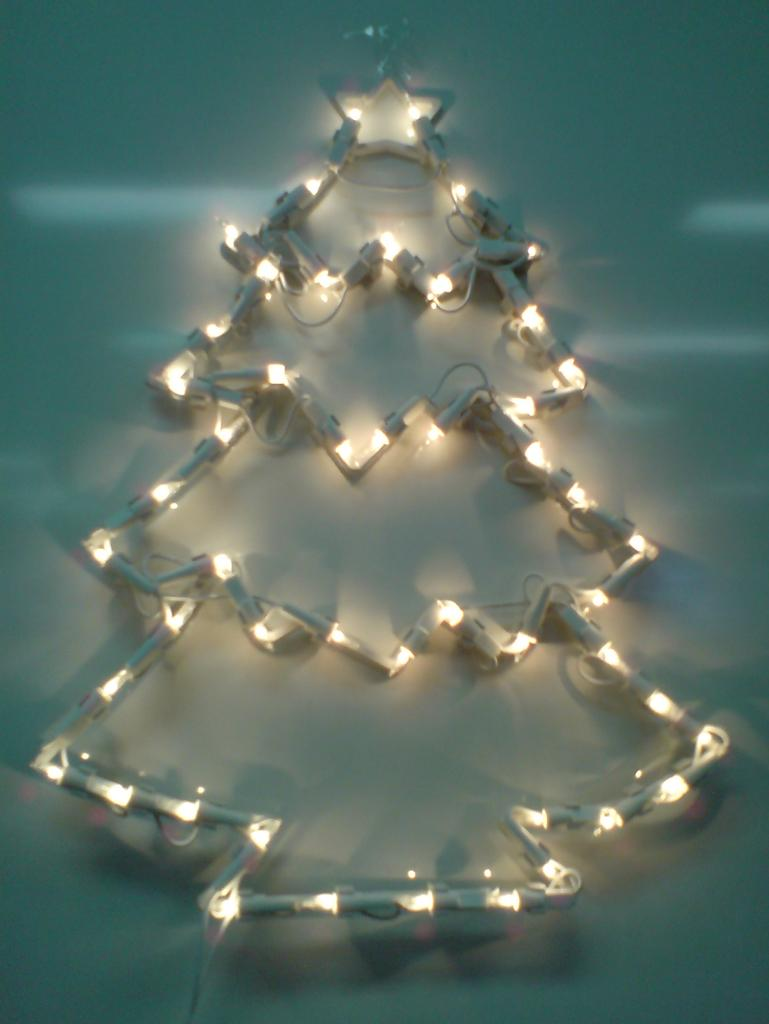What is the main subject of the image? There is a structure resembling a Christmas tree in the image. How is the Christmas tree decorated? The Christmas tree has lighting. Where is the Christmas tree located in the image? The Christmas tree is on the wall. What type of stick can be seen in the image? There is no stick present in the image. What is the view from the window in the image? There is no window present in the image. 